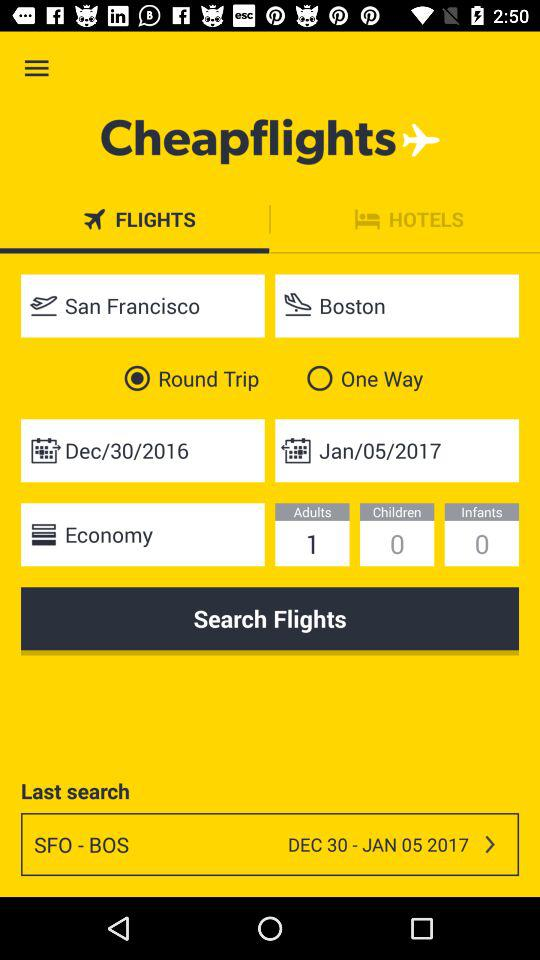What is the selected date for travel? The selected dates for travel are December 30, 2016, and January 5, 2017. 